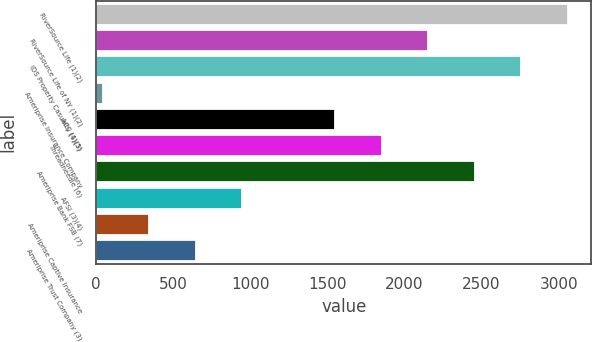<chart> <loc_0><loc_0><loc_500><loc_500><bar_chart><fcel>RiverSource Life (1)(2)<fcel>RiverSource Life of NY (1)(2)<fcel>IDS Property Casualty (1)(3)<fcel>Ameriprise Insurance Company<fcel>ACC (4)(5)<fcel>Threadneedle (6)<fcel>Ameriprise Bank FSB (7)<fcel>AFSI (3)(4)<fcel>Ameriprise Captive Insurance<fcel>Ameriprise Trust Company (3)<nl><fcel>3058<fcel>2152.9<fcel>2756.3<fcel>41<fcel>1549.5<fcel>1851.2<fcel>2454.6<fcel>946.1<fcel>342.7<fcel>644.4<nl></chart> 